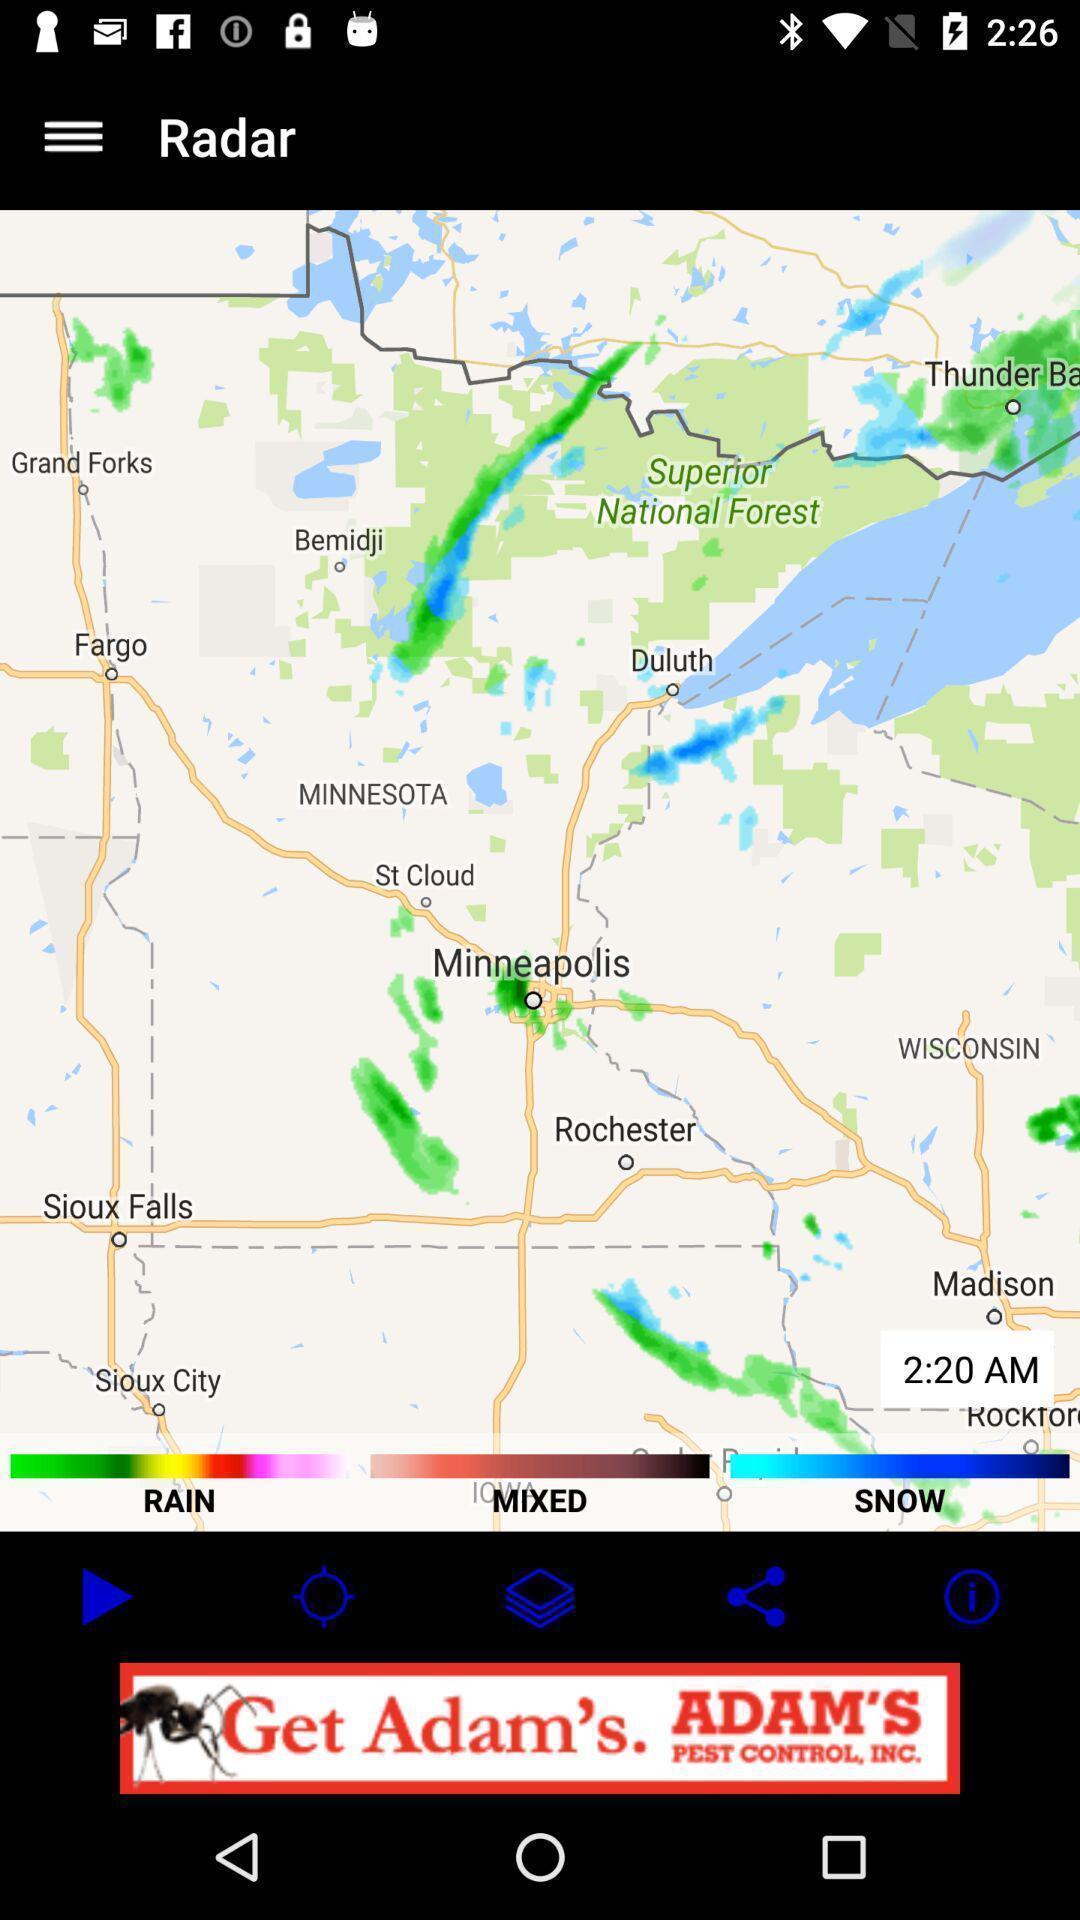Give me a summary of this screen capture. Screen shows a radar information. 